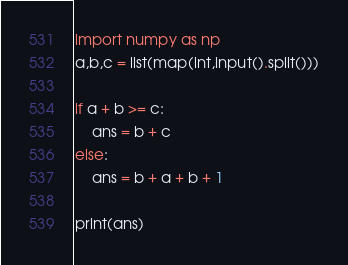Convert code to text. <code><loc_0><loc_0><loc_500><loc_500><_Python_>import numpy as np
a,b,c = list(map(int,input().split()))

if a + b >= c:
    ans = b + c
else:
    ans = b + a + b + 1

print(ans)</code> 